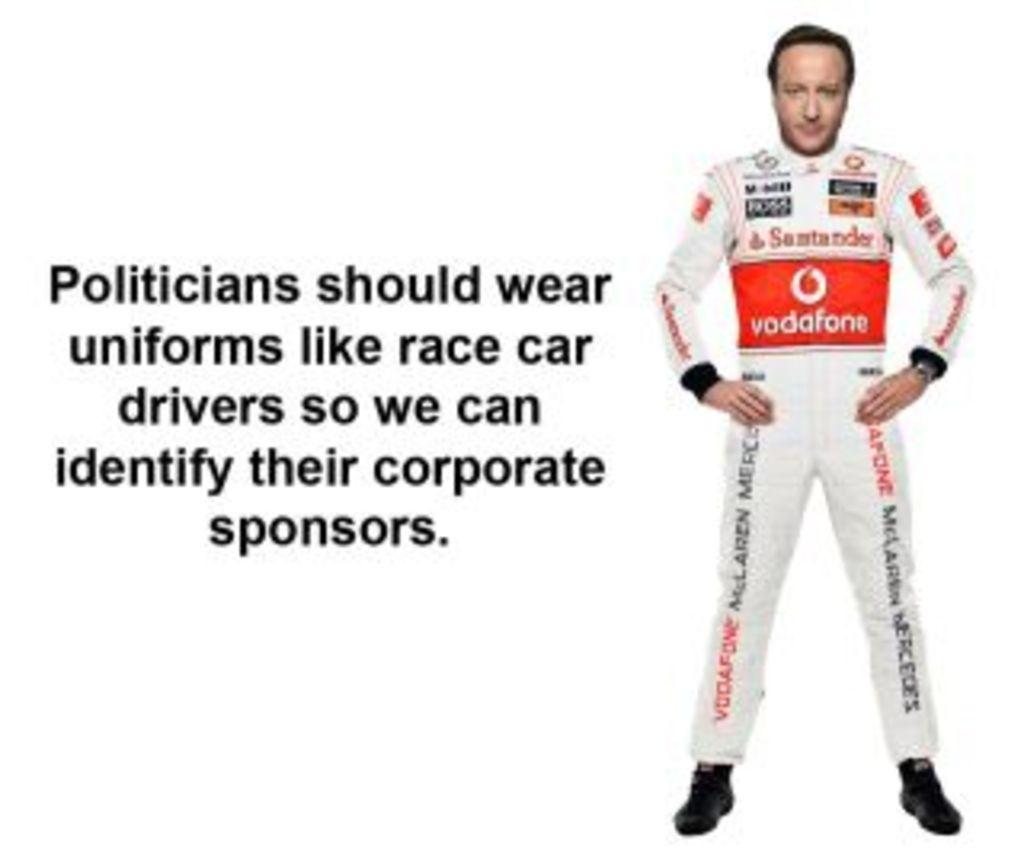<image>
Give a short and clear explanation of the subsequent image. A man in a political ad wearing a suit containing ads such as Vodafone. 